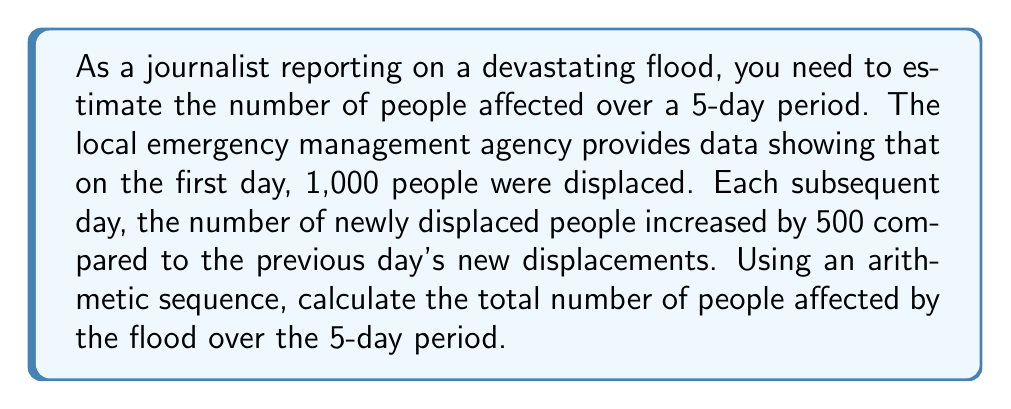Solve this math problem. Let's approach this step-by-step using an arithmetic sequence:

1) First, let's identify the components of our arithmetic sequence:
   - $a_1 = 1000$ (first term: people displaced on day 1)
   - $d = 500$ (common difference: daily increase in new displacements)
   - $n = 5$ (number of terms: 5-day period)

2) The arithmetic sequence for new displacements each day is:
   $1000, 1500, 2000, 2500, 3000$

3) To find the total number of people affected, we need to sum this sequence.
   We can use the formula for the sum of an arithmetic sequence:

   $$S_n = \frac{n}{2}(a_1 + a_n)$$

   Where $a_n$ is the last term, calculated as:
   $$a_n = a_1 + (n-1)d$$

4) Let's calculate $a_n$:
   $$a_5 = 1000 + (5-1)500 = 1000 + 2000 = 3000$$

5) Now we can calculate the sum:
   $$S_5 = \frac{5}{2}(1000 + 3000) = \frac{5}{2}(4000) = 10,000$$

Therefore, the total number of people affected over the 5-day period is 10,000.
Answer: 10,000 people 